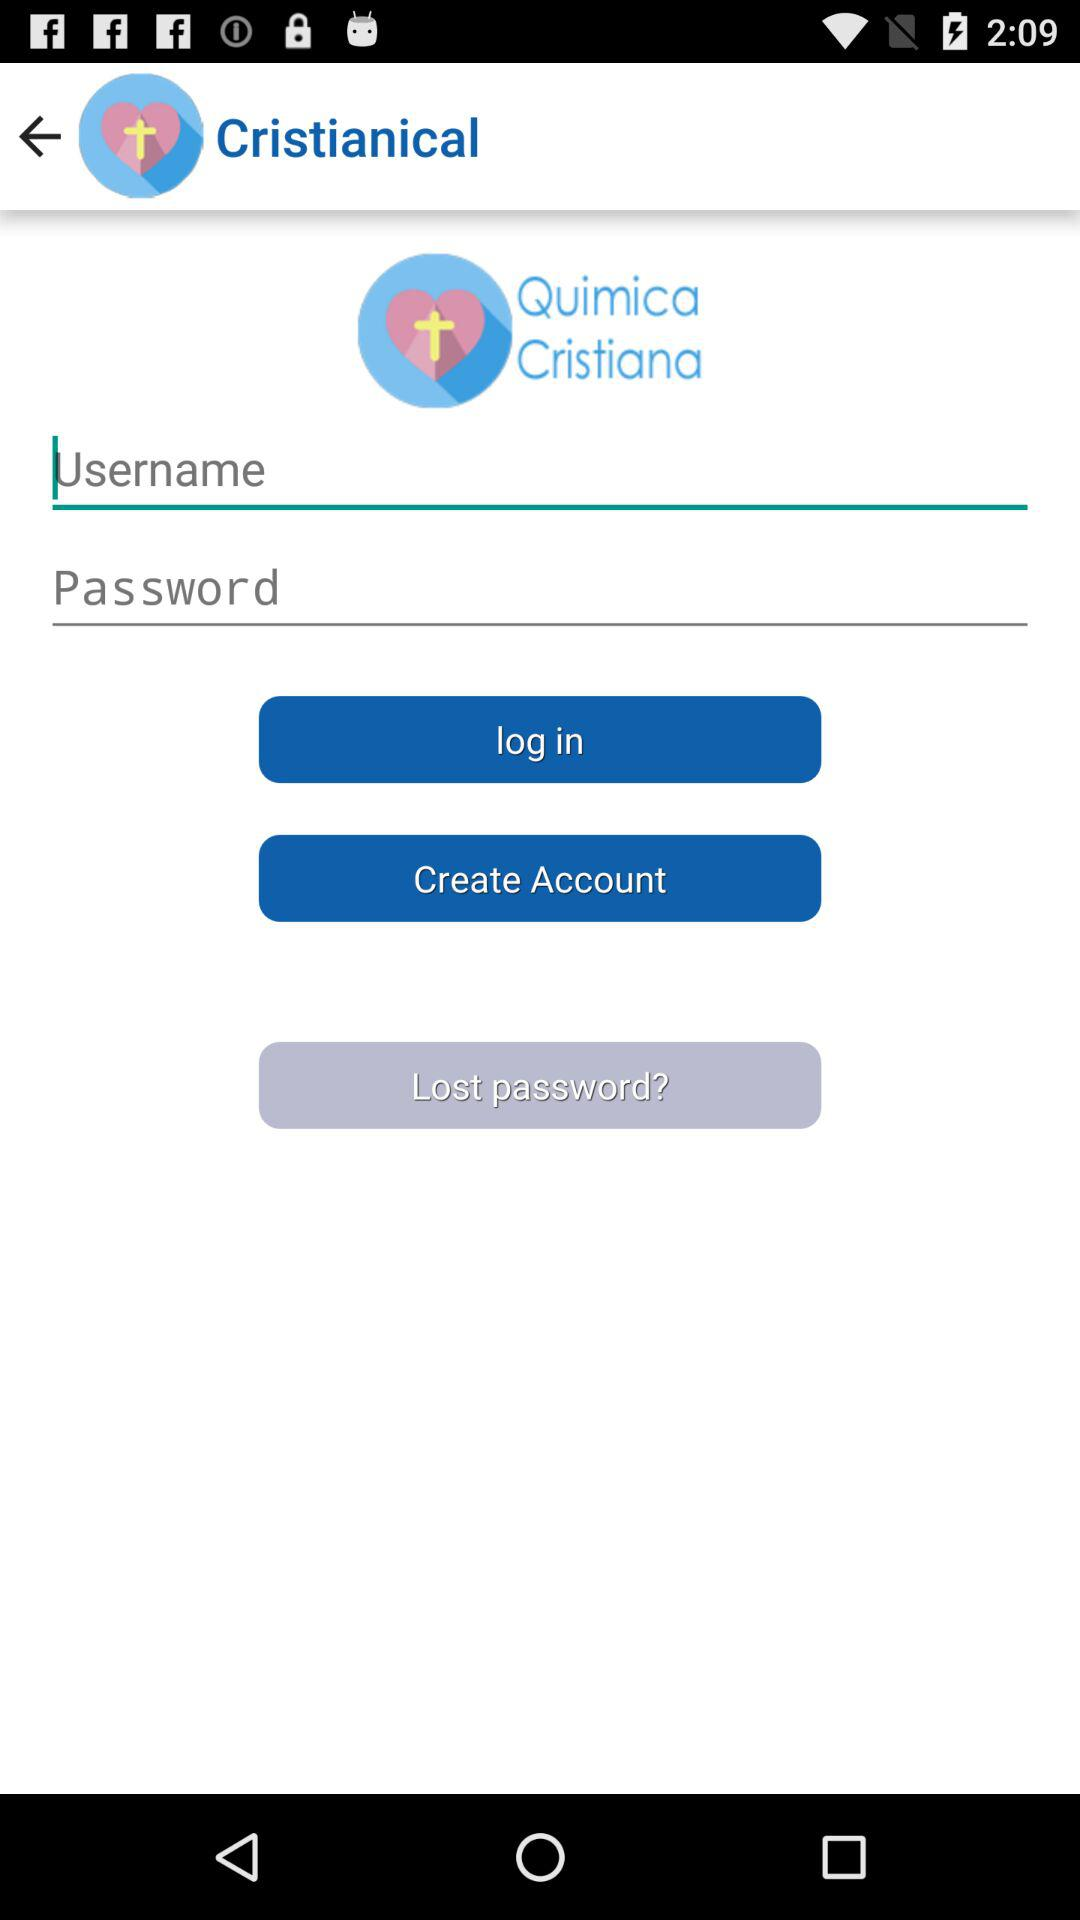What is the name of the application? The name of the application is "Christianical". 